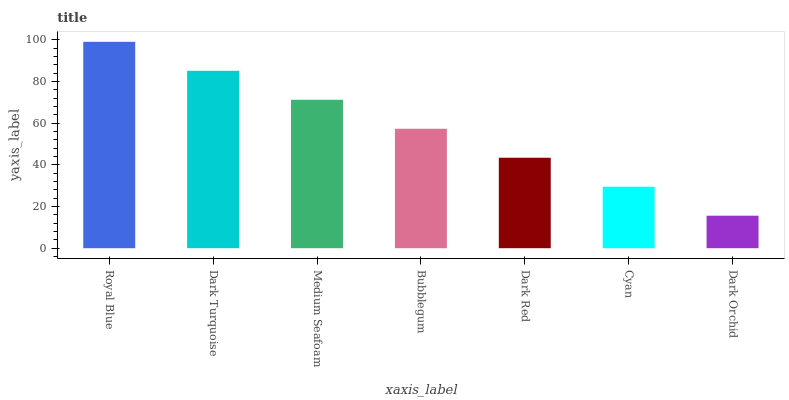Is Dark Orchid the minimum?
Answer yes or no. Yes. Is Royal Blue the maximum?
Answer yes or no. Yes. Is Dark Turquoise the minimum?
Answer yes or no. No. Is Dark Turquoise the maximum?
Answer yes or no. No. Is Royal Blue greater than Dark Turquoise?
Answer yes or no. Yes. Is Dark Turquoise less than Royal Blue?
Answer yes or no. Yes. Is Dark Turquoise greater than Royal Blue?
Answer yes or no. No. Is Royal Blue less than Dark Turquoise?
Answer yes or no. No. Is Bubblegum the high median?
Answer yes or no. Yes. Is Bubblegum the low median?
Answer yes or no. Yes. Is Dark Orchid the high median?
Answer yes or no. No. Is Royal Blue the low median?
Answer yes or no. No. 